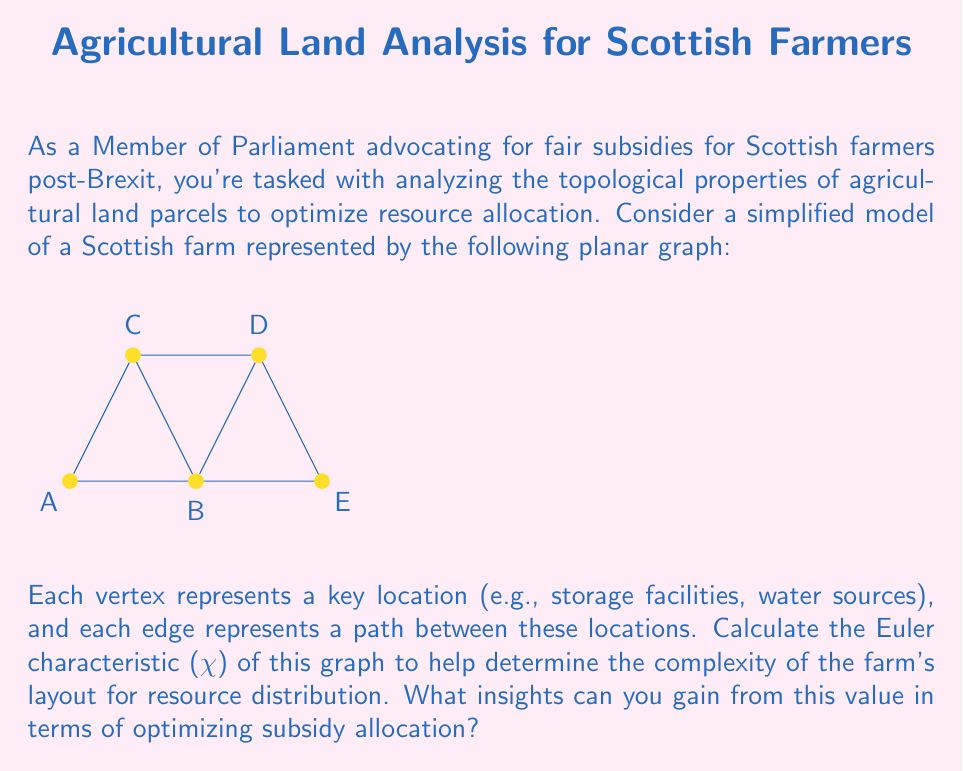Help me with this question. To calculate the Euler characteristic (χ) of the planar graph representing the Scottish farm, we'll follow these steps:

1) First, recall the formula for the Euler characteristic of a planar graph:
   
   $$χ = V - E + F$$
   
   Where:
   V = number of vertices
   E = number of edges
   F = number of faces (including the outer face)

2) Let's count each component:

   Vertices (V): The graph has 5 vertices (A, B, C, D, E)
   V = 5

   Edges (E): The graph has 8 edges (AB, BC, CD, DE, EA, AC, BD, CA)
   E = 8

   Faces (F): To count faces, we need to identify closed regions:
   - Triangle ABC
   - Triangle BCD
   - Triangle CDE
   - Outer face
   F = 4

3) Now, let's substitute these values into the Euler characteristic formula:

   $$χ = V - E + F = 5 - 8 + 4 = 1$$

4) Interpretation:
   - The Euler characteristic of 1 confirms that this is indeed a planar graph (as expected for a 2D representation of land).
   - This value indicates a relatively simple topology, which suggests straightforward connectivity between key locations on the farm.

5) Insights for subsidy allocation:
   - The planar nature of the graph (χ = 1) suggests that resources can be distributed efficiently without complex crossovers.
   - The relatively low number of faces (4) indicates that the farm has a manageable number of distinct areas, which could simplify the allocation of resources and subsidies.
   - The high connectivity (8 edges for 5 vertices) suggests good accessibility throughout the farm, which could justify equal subsidy distribution across all areas.

This topological analysis provides a foundation for arguing that subsidies could be distributed fairly across the farm, as the layout suggests relatively equal accessibility and complexity across different areas.
Answer: χ = 1; indicates simple, efficient connectivity for fair subsidy distribution 